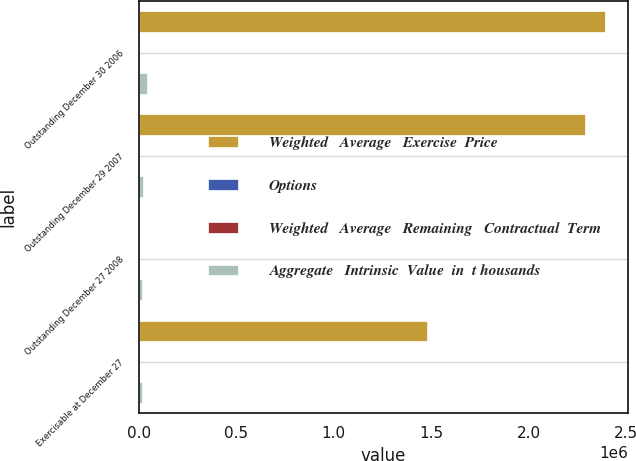Convert chart to OTSL. <chart><loc_0><loc_0><loc_500><loc_500><stacked_bar_chart><ecel><fcel>Outstanding December 30 2006<fcel>Outstanding December 29 2007<fcel>Outstanding December 27 2008<fcel>Exercisable at December 27<nl><fcel>Weighted   Average   Exercise  Price<fcel>2.39136e+06<fcel>2.28833e+06<fcel>34.14<fcel>1.47966e+06<nl><fcel>Options<fcel>29.32<fcel>33.31<fcel>34.14<fcel>28.23<nl><fcel>Weighted   Average   Remaining   Contractual  Term<fcel>6.5<fcel>6.4<fcel>6.2<fcel>4.7<nl><fcel>Aggregate   Intrinsic  Value  in  t housands<fcel>45301<fcel>22485<fcel>19296<fcel>19296<nl></chart> 